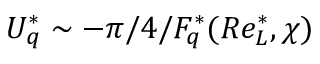<formula> <loc_0><loc_0><loc_500><loc_500>U _ { q } ^ { * } \sim - \pi / 4 / F _ { q } ^ { * } ( R e _ { L } ^ { * } , \chi )</formula> 